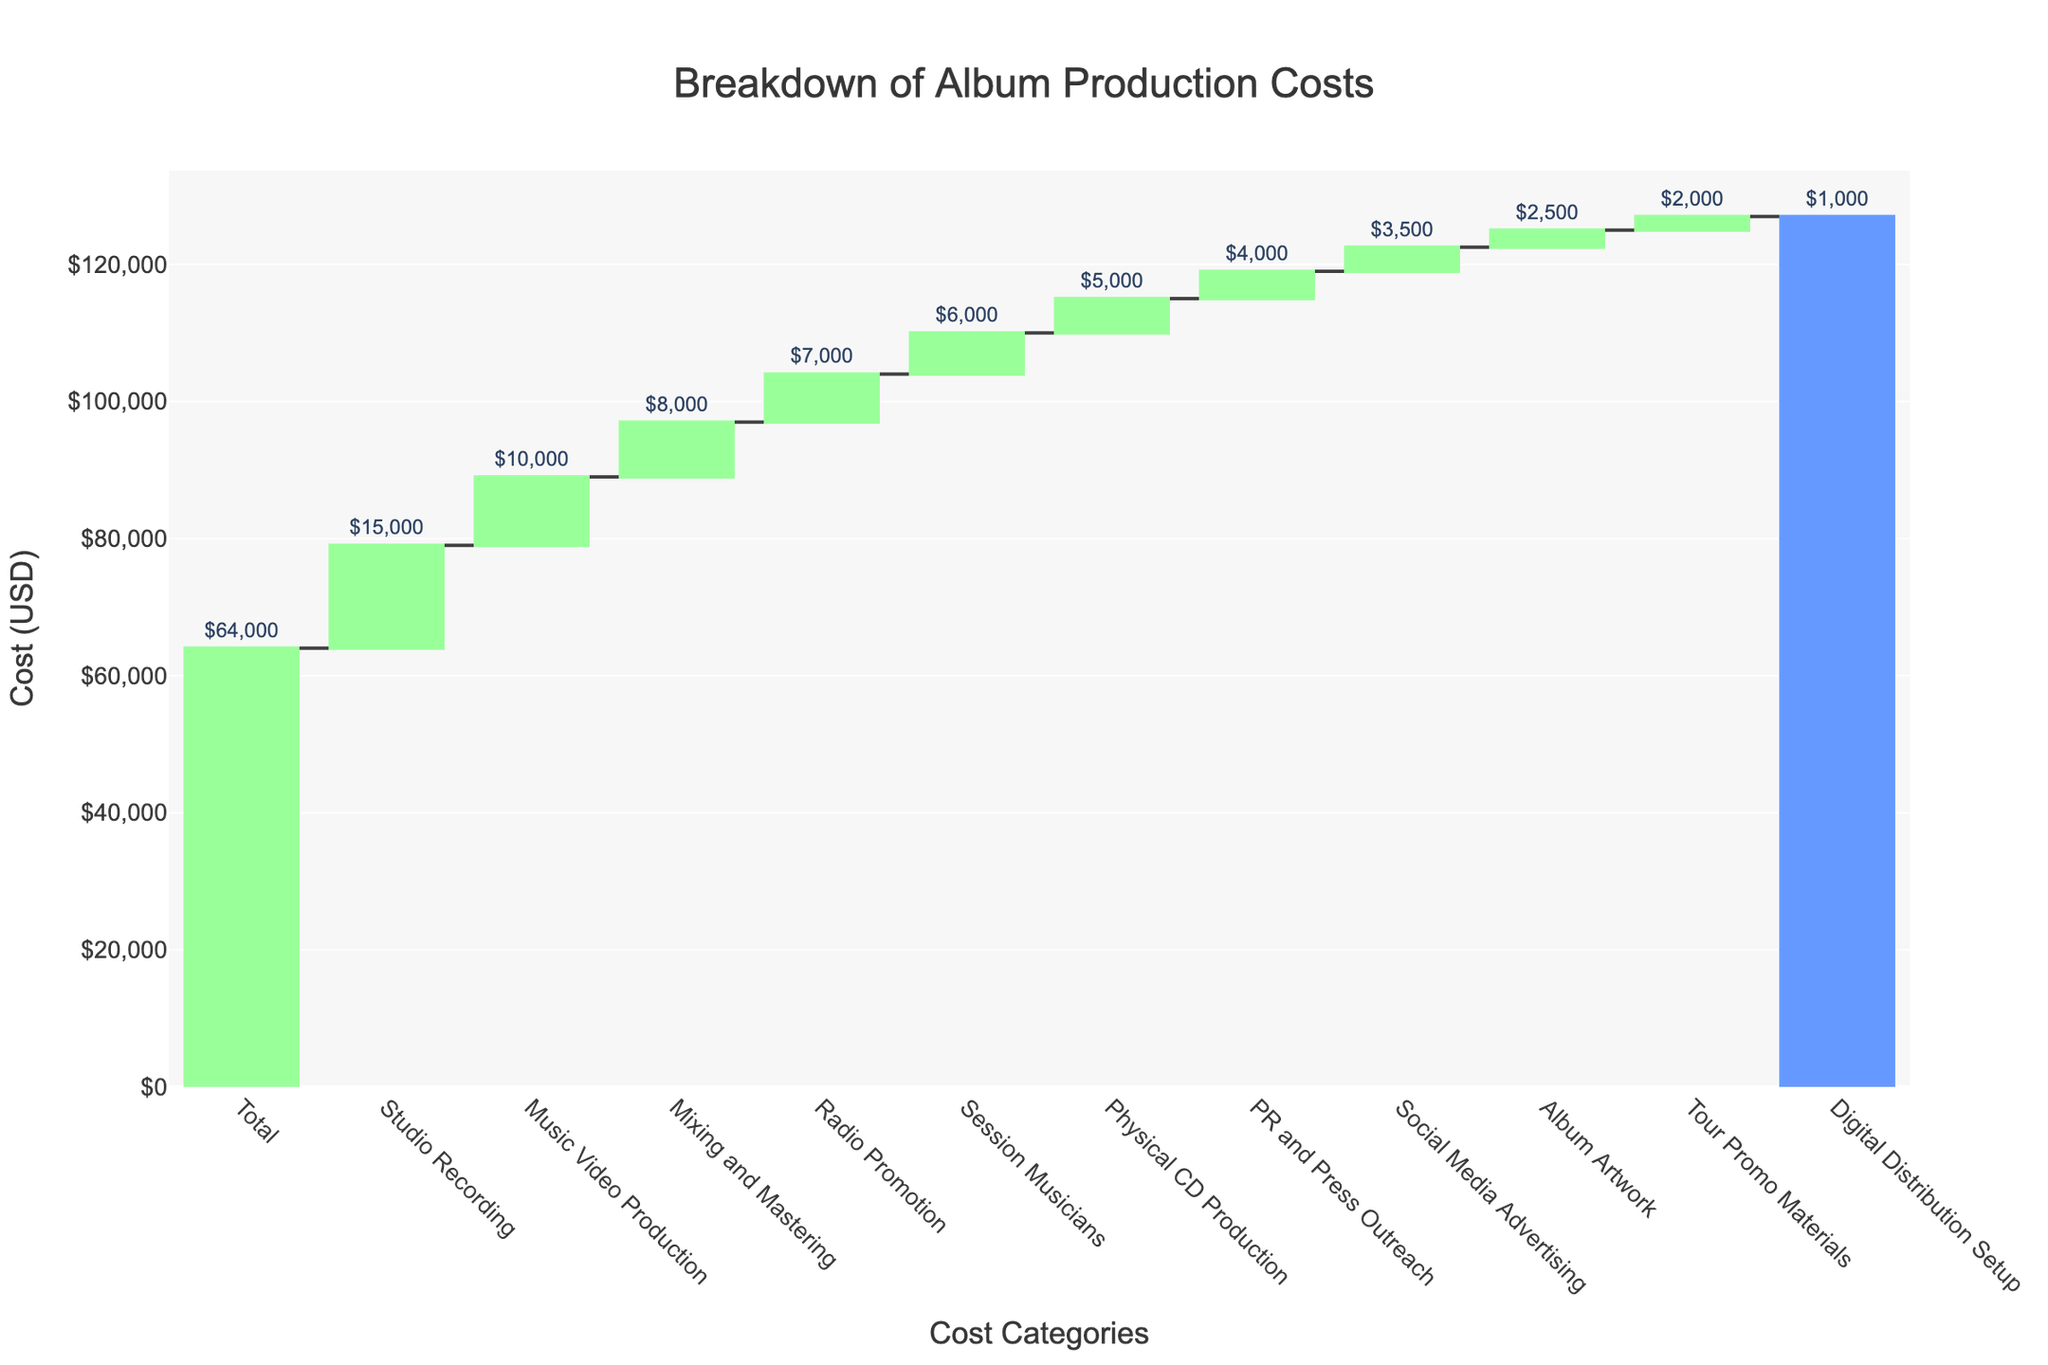Which cost category has the highest expense? The element with the tallest bar in the waterfall chart represents the category with the highest expense. Looking at the chart, the "Studio Recording" bar reaches the highest value.
Answer: Studio Recording How much was spent on Music Video Production? Locate the "Music Video Production" bar on the x-axis. The y-axis value for this category is $10,000. This is also confirmed by the text label outside the bar that shows "$10,000".
Answer: $10,000 What are the three lowest cost categories? Identify the three shortest bars in the chart. These represent the smallest expenses. The categories are "Digital Distribution Setup", "Tour Promo Materials", and "Album Artwork" based on their heights.
Answer: Digital Distribution Setup, Tour Promo Materials, Album Artwork What is the total cost presented at the final bar of the waterfall chart? The final bar, often marked differently in color, signifies the total cost. The label outside this bar indicates the total. The total cost on the final bar reads "$64,000".
Answer: $64,000 How much more was spent on Radio Promotion compared to Social Media Advertising? First, find the values for "Radio Promotion" and "Social Media Advertising" on their respective bars, which are $7,000 and $3,500. Subtract the smaller value from the larger value to find the difference: $7,000 - $3,500 = $3,500.
Answer: $3,500 What's the combined cost of Mixing and Mastering and Session Musicians? Locate the bars for "Mixing and Mastering" and "Session Musicians". Their values are $8,000 and $6,000, respectively. Adding these together gives $8,000 + $6,000 = $14,000.
Answer: $14,000 What is the average cost spent on Social Media Advertising, PR and Press Outreach, and Tour Promo Materials? Find the values for the three categories: $3,500 (Social Media Advertising), $4,000 (PR and Press Outreach), and $2,000 (Tour Promo Materials). Sum them: $3,500 + $4,000 + $2,000 = $9,500. Divide by the number of categories, which is 3: $9,500 / 3 = $3,167 approximately.
Answer: $3,167 Which categories have values higher than $5,000? Identify and list the bars with values exceeding $5,000: "Studio Recording" ($15,000), "Mixing and Mastering" ($8,000), "Session Musicians" ($6,000), "Music Video Production" ($10,000), and "Radio Promotion" ($7,000).
Answer: Studio Recording, Mixing and Mastering, Session Musicians, Music Video Production, Radio Promotion What is the difference between the highest expense category and the lowest expense category? The highest expense is "Studio Recording" with $15,000, and the lowest is "Digital Distribution Setup" with $1,000. Subtract the lower value from the higher value: $15,000 - $1,000 = $14,000.
Answer: $14,000 